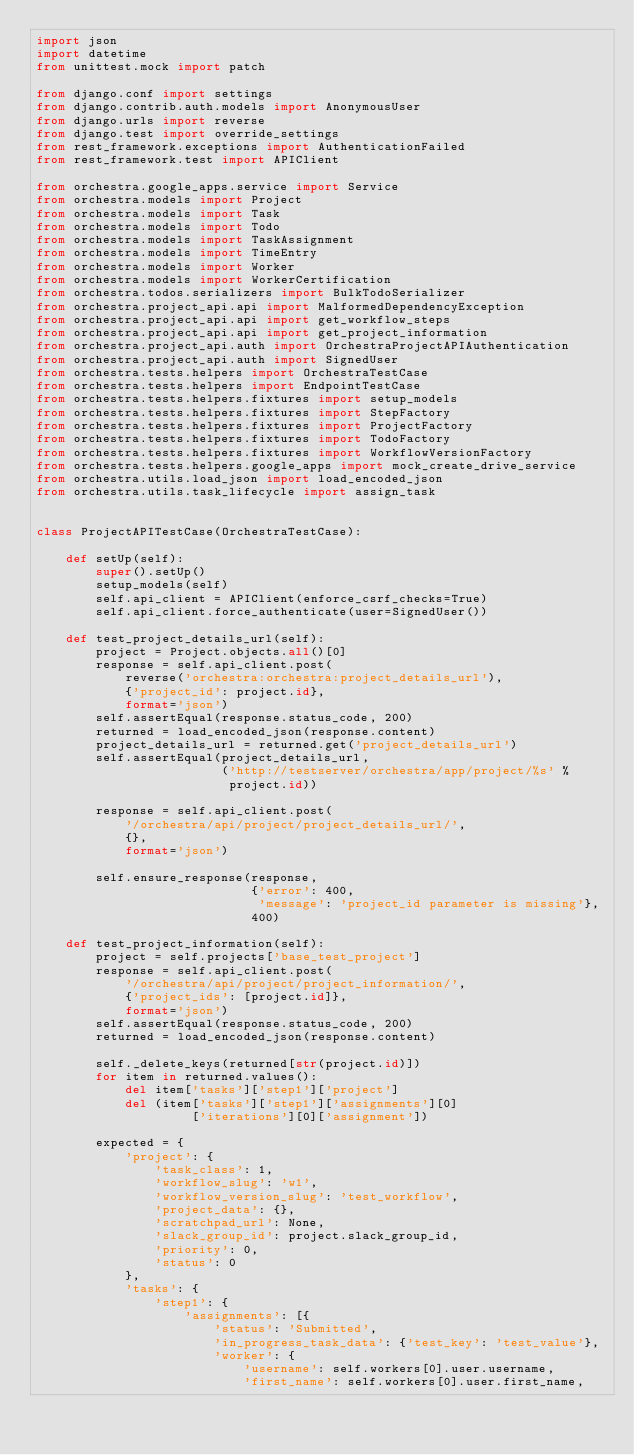<code> <loc_0><loc_0><loc_500><loc_500><_Python_>import json
import datetime
from unittest.mock import patch

from django.conf import settings
from django.contrib.auth.models import AnonymousUser
from django.urls import reverse
from django.test import override_settings
from rest_framework.exceptions import AuthenticationFailed
from rest_framework.test import APIClient

from orchestra.google_apps.service import Service
from orchestra.models import Project
from orchestra.models import Task
from orchestra.models import Todo
from orchestra.models import TaskAssignment
from orchestra.models import TimeEntry
from orchestra.models import Worker
from orchestra.models import WorkerCertification
from orchestra.todos.serializers import BulkTodoSerializer
from orchestra.project_api.api import MalformedDependencyException
from orchestra.project_api.api import get_workflow_steps
from orchestra.project_api.api import get_project_information
from orchestra.project_api.auth import OrchestraProjectAPIAuthentication
from orchestra.project_api.auth import SignedUser
from orchestra.tests.helpers import OrchestraTestCase
from orchestra.tests.helpers import EndpointTestCase
from orchestra.tests.helpers.fixtures import setup_models
from orchestra.tests.helpers.fixtures import StepFactory
from orchestra.tests.helpers.fixtures import ProjectFactory
from orchestra.tests.helpers.fixtures import TodoFactory
from orchestra.tests.helpers.fixtures import WorkflowVersionFactory
from orchestra.tests.helpers.google_apps import mock_create_drive_service
from orchestra.utils.load_json import load_encoded_json
from orchestra.utils.task_lifecycle import assign_task


class ProjectAPITestCase(OrchestraTestCase):

    def setUp(self):
        super().setUp()
        setup_models(self)
        self.api_client = APIClient(enforce_csrf_checks=True)
        self.api_client.force_authenticate(user=SignedUser())

    def test_project_details_url(self):
        project = Project.objects.all()[0]
        response = self.api_client.post(
            reverse('orchestra:orchestra:project_details_url'),
            {'project_id': project.id},
            format='json')
        self.assertEqual(response.status_code, 200)
        returned = load_encoded_json(response.content)
        project_details_url = returned.get('project_details_url')
        self.assertEqual(project_details_url,
                         ('http://testserver/orchestra/app/project/%s' %
                          project.id))

        response = self.api_client.post(
            '/orchestra/api/project/project_details_url/',
            {},
            format='json')

        self.ensure_response(response,
                             {'error': 400,
                              'message': 'project_id parameter is missing'},
                             400)

    def test_project_information(self):
        project = self.projects['base_test_project']
        response = self.api_client.post(
            '/orchestra/api/project/project_information/',
            {'project_ids': [project.id]},
            format='json')
        self.assertEqual(response.status_code, 200)
        returned = load_encoded_json(response.content)

        self._delete_keys(returned[str(project.id)])
        for item in returned.values():
            del item['tasks']['step1']['project']
            del (item['tasks']['step1']['assignments'][0]
                     ['iterations'][0]['assignment'])

        expected = {
            'project': {
                'task_class': 1,
                'workflow_slug': 'w1',
                'workflow_version_slug': 'test_workflow',
                'project_data': {},
                'scratchpad_url': None,
                'slack_group_id': project.slack_group_id,
                'priority': 0,
                'status': 0
            },
            'tasks': {
                'step1': {
                    'assignments': [{
                        'status': 'Submitted',
                        'in_progress_task_data': {'test_key': 'test_value'},
                        'worker': {
                            'username': self.workers[0].user.username,
                            'first_name': self.workers[0].user.first_name,</code> 